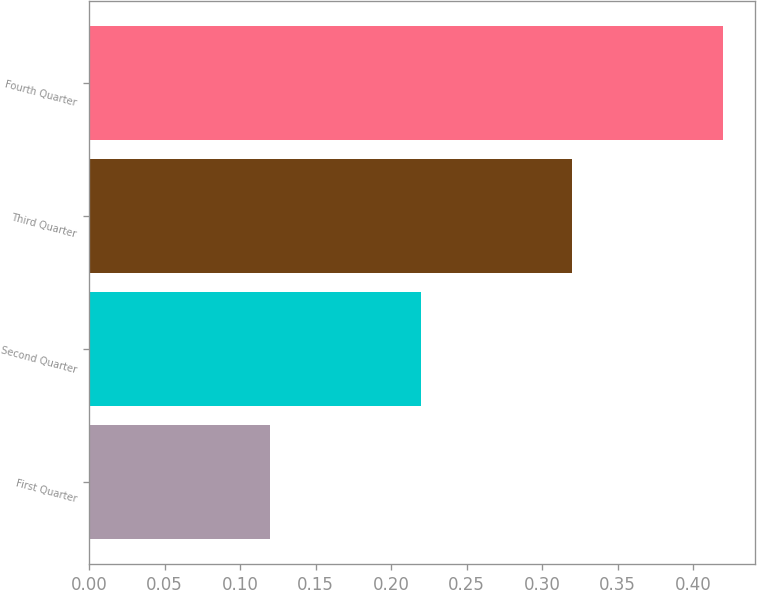Convert chart. <chart><loc_0><loc_0><loc_500><loc_500><bar_chart><fcel>First Quarter<fcel>Second Quarter<fcel>Third Quarter<fcel>Fourth Quarter<nl><fcel>0.12<fcel>0.22<fcel>0.32<fcel>0.42<nl></chart> 